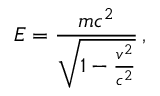Convert formula to latex. <formula><loc_0><loc_0><loc_500><loc_500>E = \frac { m c ^ { 2 } } { \sqrt { 1 - \frac { v ^ { 2 } } { c ^ { 2 } } } } \, ,</formula> 